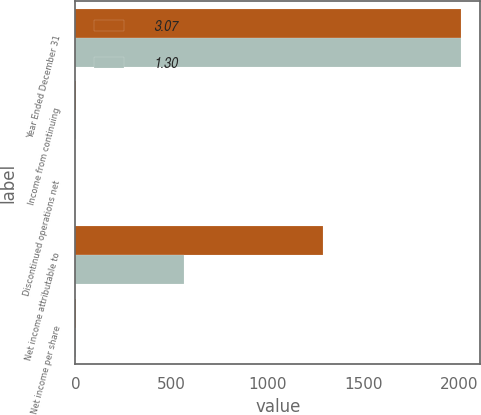Convert chart to OTSL. <chart><loc_0><loc_0><loc_500><loc_500><stacked_bar_chart><ecel><fcel>Year Ended December 31<fcel>Income from continuing<fcel>Discontinued operations net<fcel>Net income attributable to<fcel>Net income per share<nl><fcel>3.07<fcel>2010<fcel>3.11<fcel>0.04<fcel>1288<fcel>3.07<nl><fcel>1.3<fcel>2009<fcel>1.31<fcel>0.01<fcel>564<fcel>1.3<nl></chart> 